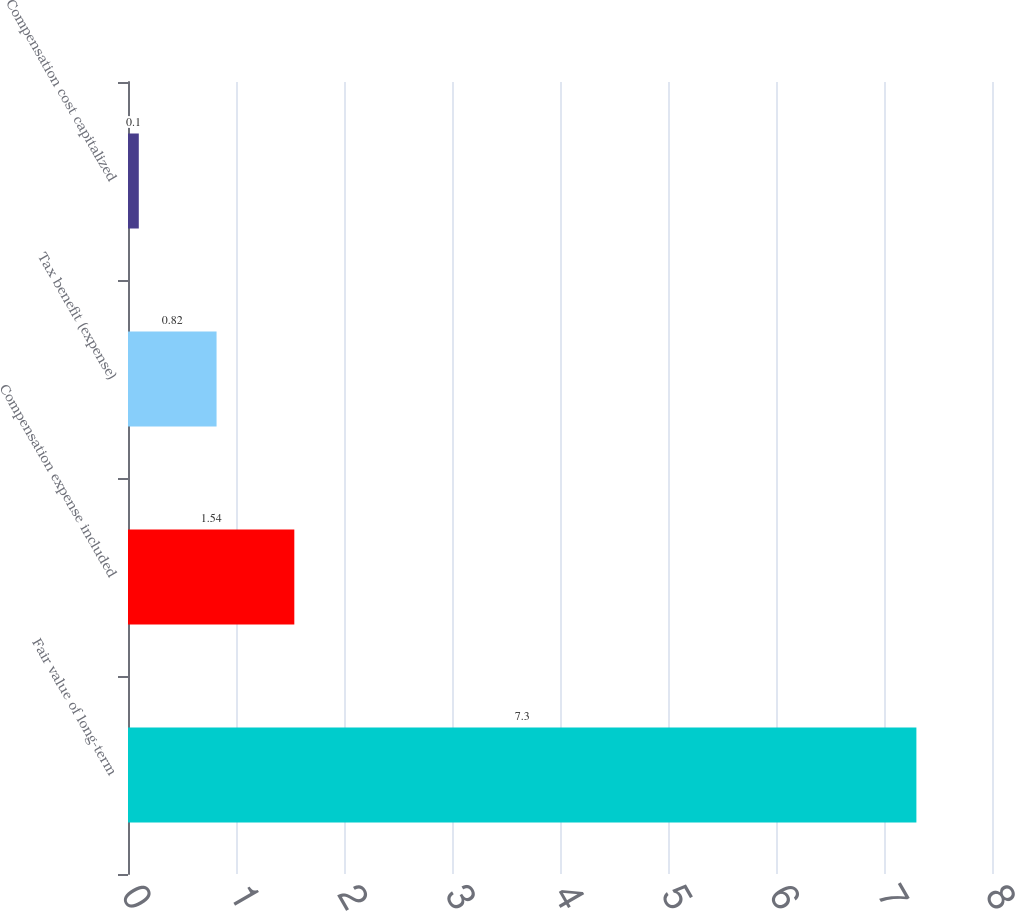Convert chart. <chart><loc_0><loc_0><loc_500><loc_500><bar_chart><fcel>Fair value of long-term<fcel>Compensation expense included<fcel>Tax benefit (expense)<fcel>Compensation cost capitalized<nl><fcel>7.3<fcel>1.54<fcel>0.82<fcel>0.1<nl></chart> 